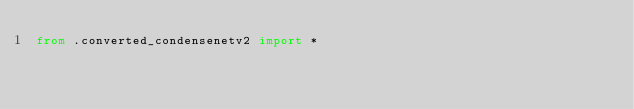<code> <loc_0><loc_0><loc_500><loc_500><_Python_>from .converted_condensenetv2 import *
</code> 